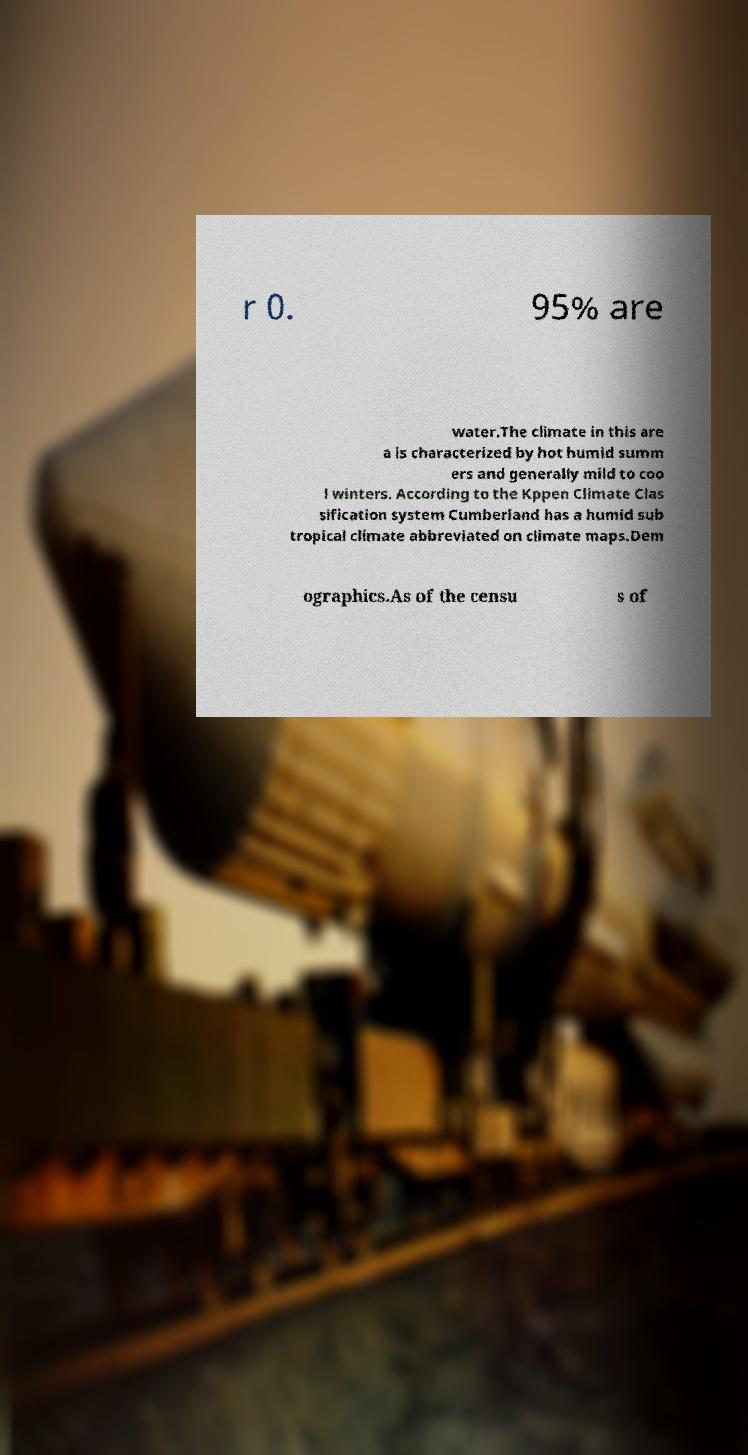Can you accurately transcribe the text from the provided image for me? r 0. 95% are water.The climate in this are a is characterized by hot humid summ ers and generally mild to coo l winters. According to the Kppen Climate Clas sification system Cumberland has a humid sub tropical climate abbreviated on climate maps.Dem ographics.As of the censu s of 